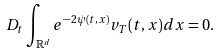Convert formula to latex. <formula><loc_0><loc_0><loc_500><loc_500>D _ { t } \int _ { \mathbb { R } ^ { d } } e ^ { - 2 \psi ( t , x ) } v _ { T } ( t , x ) d x = 0 .</formula> 